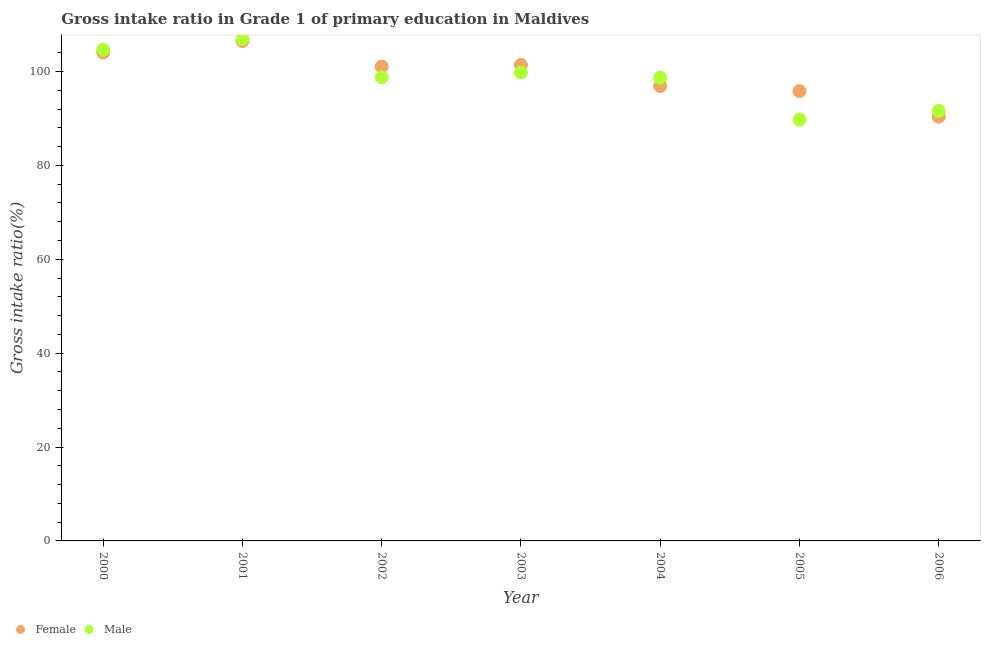How many different coloured dotlines are there?
Offer a very short reply. 2. What is the gross intake ratio(female) in 2002?
Keep it short and to the point. 101.03. Across all years, what is the maximum gross intake ratio(male)?
Provide a short and direct response. 106.93. Across all years, what is the minimum gross intake ratio(male)?
Offer a terse response. 89.74. In which year was the gross intake ratio(male) maximum?
Keep it short and to the point. 2001. What is the total gross intake ratio(female) in the graph?
Give a very brief answer. 695.97. What is the difference between the gross intake ratio(male) in 2001 and that in 2003?
Give a very brief answer. 7.13. What is the difference between the gross intake ratio(female) in 2002 and the gross intake ratio(male) in 2005?
Ensure brevity in your answer.  11.29. What is the average gross intake ratio(male) per year?
Provide a short and direct response. 98.59. In the year 2006, what is the difference between the gross intake ratio(female) and gross intake ratio(male)?
Make the answer very short. -1.24. In how many years, is the gross intake ratio(female) greater than 76 %?
Provide a short and direct response. 7. What is the ratio of the gross intake ratio(male) in 2005 to that in 2006?
Provide a succinct answer. 0.98. Is the difference between the gross intake ratio(female) in 2003 and 2004 greater than the difference between the gross intake ratio(male) in 2003 and 2004?
Your response must be concise. Yes. What is the difference between the highest and the second highest gross intake ratio(female)?
Your answer should be very brief. 2.44. What is the difference between the highest and the lowest gross intake ratio(female)?
Make the answer very short. 16.12. In how many years, is the gross intake ratio(female) greater than the average gross intake ratio(female) taken over all years?
Give a very brief answer. 4. Is the sum of the gross intake ratio(female) in 2002 and 2005 greater than the maximum gross intake ratio(male) across all years?
Offer a terse response. Yes. Is the gross intake ratio(female) strictly less than the gross intake ratio(male) over the years?
Ensure brevity in your answer.  No. How many years are there in the graph?
Your response must be concise. 7. How many legend labels are there?
Make the answer very short. 2. What is the title of the graph?
Give a very brief answer. Gross intake ratio in Grade 1 of primary education in Maldives. What is the label or title of the Y-axis?
Keep it short and to the point. Gross intake ratio(%). What is the Gross intake ratio(%) of Female in 2000?
Your answer should be very brief. 104.04. What is the Gross intake ratio(%) in Male in 2000?
Offer a terse response. 104.63. What is the Gross intake ratio(%) of Female in 2001?
Your answer should be compact. 106.48. What is the Gross intake ratio(%) of Male in 2001?
Offer a very short reply. 106.93. What is the Gross intake ratio(%) of Female in 2002?
Your response must be concise. 101.03. What is the Gross intake ratio(%) of Male in 2002?
Your response must be concise. 98.77. What is the Gross intake ratio(%) of Female in 2003?
Offer a very short reply. 101.36. What is the Gross intake ratio(%) in Male in 2003?
Provide a succinct answer. 99.81. What is the Gross intake ratio(%) in Female in 2004?
Offer a terse response. 96.88. What is the Gross intake ratio(%) of Male in 2004?
Ensure brevity in your answer.  98.67. What is the Gross intake ratio(%) of Female in 2005?
Your answer should be compact. 95.82. What is the Gross intake ratio(%) in Male in 2005?
Ensure brevity in your answer.  89.74. What is the Gross intake ratio(%) in Female in 2006?
Provide a succinct answer. 90.36. What is the Gross intake ratio(%) of Male in 2006?
Ensure brevity in your answer.  91.59. Across all years, what is the maximum Gross intake ratio(%) in Female?
Offer a terse response. 106.48. Across all years, what is the maximum Gross intake ratio(%) in Male?
Provide a succinct answer. 106.93. Across all years, what is the minimum Gross intake ratio(%) of Female?
Your answer should be very brief. 90.36. Across all years, what is the minimum Gross intake ratio(%) of Male?
Provide a short and direct response. 89.74. What is the total Gross intake ratio(%) in Female in the graph?
Give a very brief answer. 695.97. What is the total Gross intake ratio(%) of Male in the graph?
Your answer should be compact. 690.14. What is the difference between the Gross intake ratio(%) in Female in 2000 and that in 2001?
Keep it short and to the point. -2.44. What is the difference between the Gross intake ratio(%) in Male in 2000 and that in 2001?
Ensure brevity in your answer.  -2.3. What is the difference between the Gross intake ratio(%) in Female in 2000 and that in 2002?
Your answer should be very brief. 3.01. What is the difference between the Gross intake ratio(%) in Male in 2000 and that in 2002?
Offer a terse response. 5.86. What is the difference between the Gross intake ratio(%) in Female in 2000 and that in 2003?
Provide a short and direct response. 2.67. What is the difference between the Gross intake ratio(%) of Male in 2000 and that in 2003?
Your answer should be compact. 4.82. What is the difference between the Gross intake ratio(%) in Female in 2000 and that in 2004?
Your answer should be very brief. 7.16. What is the difference between the Gross intake ratio(%) of Male in 2000 and that in 2004?
Provide a short and direct response. 5.96. What is the difference between the Gross intake ratio(%) of Female in 2000 and that in 2005?
Provide a succinct answer. 8.22. What is the difference between the Gross intake ratio(%) in Male in 2000 and that in 2005?
Your answer should be very brief. 14.89. What is the difference between the Gross intake ratio(%) in Female in 2000 and that in 2006?
Provide a short and direct response. 13.68. What is the difference between the Gross intake ratio(%) of Male in 2000 and that in 2006?
Your answer should be very brief. 13.04. What is the difference between the Gross intake ratio(%) in Female in 2001 and that in 2002?
Offer a very short reply. 5.45. What is the difference between the Gross intake ratio(%) of Male in 2001 and that in 2002?
Keep it short and to the point. 8.16. What is the difference between the Gross intake ratio(%) of Female in 2001 and that in 2003?
Offer a very short reply. 5.12. What is the difference between the Gross intake ratio(%) in Male in 2001 and that in 2003?
Give a very brief answer. 7.13. What is the difference between the Gross intake ratio(%) of Female in 2001 and that in 2004?
Offer a very short reply. 9.6. What is the difference between the Gross intake ratio(%) of Male in 2001 and that in 2004?
Your answer should be compact. 8.27. What is the difference between the Gross intake ratio(%) of Female in 2001 and that in 2005?
Give a very brief answer. 10.67. What is the difference between the Gross intake ratio(%) of Male in 2001 and that in 2005?
Provide a succinct answer. 17.2. What is the difference between the Gross intake ratio(%) in Female in 2001 and that in 2006?
Your response must be concise. 16.12. What is the difference between the Gross intake ratio(%) in Male in 2001 and that in 2006?
Your response must be concise. 15.34. What is the difference between the Gross intake ratio(%) in Female in 2002 and that in 2003?
Ensure brevity in your answer.  -0.34. What is the difference between the Gross intake ratio(%) of Male in 2002 and that in 2003?
Offer a terse response. -1.03. What is the difference between the Gross intake ratio(%) of Female in 2002 and that in 2004?
Offer a terse response. 4.14. What is the difference between the Gross intake ratio(%) of Male in 2002 and that in 2004?
Make the answer very short. 0.1. What is the difference between the Gross intake ratio(%) in Female in 2002 and that in 2005?
Offer a terse response. 5.21. What is the difference between the Gross intake ratio(%) in Male in 2002 and that in 2005?
Give a very brief answer. 9.04. What is the difference between the Gross intake ratio(%) in Female in 2002 and that in 2006?
Your answer should be very brief. 10.67. What is the difference between the Gross intake ratio(%) of Male in 2002 and that in 2006?
Offer a terse response. 7.18. What is the difference between the Gross intake ratio(%) of Female in 2003 and that in 2004?
Ensure brevity in your answer.  4.48. What is the difference between the Gross intake ratio(%) in Male in 2003 and that in 2004?
Give a very brief answer. 1.14. What is the difference between the Gross intake ratio(%) of Female in 2003 and that in 2005?
Offer a terse response. 5.55. What is the difference between the Gross intake ratio(%) of Male in 2003 and that in 2005?
Your answer should be compact. 10.07. What is the difference between the Gross intake ratio(%) in Female in 2003 and that in 2006?
Make the answer very short. 11.01. What is the difference between the Gross intake ratio(%) in Male in 2003 and that in 2006?
Your answer should be very brief. 8.21. What is the difference between the Gross intake ratio(%) in Female in 2004 and that in 2005?
Your answer should be very brief. 1.07. What is the difference between the Gross intake ratio(%) of Male in 2004 and that in 2005?
Provide a succinct answer. 8.93. What is the difference between the Gross intake ratio(%) of Female in 2004 and that in 2006?
Provide a short and direct response. 6.53. What is the difference between the Gross intake ratio(%) in Male in 2004 and that in 2006?
Provide a short and direct response. 7.07. What is the difference between the Gross intake ratio(%) of Female in 2005 and that in 2006?
Make the answer very short. 5.46. What is the difference between the Gross intake ratio(%) of Male in 2005 and that in 2006?
Provide a short and direct response. -1.86. What is the difference between the Gross intake ratio(%) of Female in 2000 and the Gross intake ratio(%) of Male in 2001?
Ensure brevity in your answer.  -2.9. What is the difference between the Gross intake ratio(%) in Female in 2000 and the Gross intake ratio(%) in Male in 2002?
Your answer should be compact. 5.27. What is the difference between the Gross intake ratio(%) in Female in 2000 and the Gross intake ratio(%) in Male in 2003?
Your answer should be very brief. 4.23. What is the difference between the Gross intake ratio(%) in Female in 2000 and the Gross intake ratio(%) in Male in 2004?
Keep it short and to the point. 5.37. What is the difference between the Gross intake ratio(%) of Female in 2000 and the Gross intake ratio(%) of Male in 2005?
Give a very brief answer. 14.3. What is the difference between the Gross intake ratio(%) of Female in 2000 and the Gross intake ratio(%) of Male in 2006?
Your answer should be compact. 12.44. What is the difference between the Gross intake ratio(%) in Female in 2001 and the Gross intake ratio(%) in Male in 2002?
Give a very brief answer. 7.71. What is the difference between the Gross intake ratio(%) in Female in 2001 and the Gross intake ratio(%) in Male in 2003?
Offer a terse response. 6.68. What is the difference between the Gross intake ratio(%) of Female in 2001 and the Gross intake ratio(%) of Male in 2004?
Make the answer very short. 7.81. What is the difference between the Gross intake ratio(%) of Female in 2001 and the Gross intake ratio(%) of Male in 2005?
Your answer should be compact. 16.75. What is the difference between the Gross intake ratio(%) in Female in 2001 and the Gross intake ratio(%) in Male in 2006?
Offer a terse response. 14.89. What is the difference between the Gross intake ratio(%) in Female in 2002 and the Gross intake ratio(%) in Male in 2003?
Keep it short and to the point. 1.22. What is the difference between the Gross intake ratio(%) of Female in 2002 and the Gross intake ratio(%) of Male in 2004?
Keep it short and to the point. 2.36. What is the difference between the Gross intake ratio(%) of Female in 2002 and the Gross intake ratio(%) of Male in 2005?
Give a very brief answer. 11.29. What is the difference between the Gross intake ratio(%) in Female in 2002 and the Gross intake ratio(%) in Male in 2006?
Make the answer very short. 9.43. What is the difference between the Gross intake ratio(%) of Female in 2003 and the Gross intake ratio(%) of Male in 2004?
Make the answer very short. 2.7. What is the difference between the Gross intake ratio(%) in Female in 2003 and the Gross intake ratio(%) in Male in 2005?
Make the answer very short. 11.63. What is the difference between the Gross intake ratio(%) of Female in 2003 and the Gross intake ratio(%) of Male in 2006?
Provide a succinct answer. 9.77. What is the difference between the Gross intake ratio(%) of Female in 2004 and the Gross intake ratio(%) of Male in 2005?
Provide a succinct answer. 7.15. What is the difference between the Gross intake ratio(%) of Female in 2004 and the Gross intake ratio(%) of Male in 2006?
Offer a very short reply. 5.29. What is the difference between the Gross intake ratio(%) in Female in 2005 and the Gross intake ratio(%) in Male in 2006?
Offer a very short reply. 4.22. What is the average Gross intake ratio(%) in Female per year?
Make the answer very short. 99.42. What is the average Gross intake ratio(%) in Male per year?
Give a very brief answer. 98.59. In the year 2000, what is the difference between the Gross intake ratio(%) in Female and Gross intake ratio(%) in Male?
Your answer should be very brief. -0.59. In the year 2001, what is the difference between the Gross intake ratio(%) of Female and Gross intake ratio(%) of Male?
Make the answer very short. -0.45. In the year 2002, what is the difference between the Gross intake ratio(%) in Female and Gross intake ratio(%) in Male?
Ensure brevity in your answer.  2.26. In the year 2003, what is the difference between the Gross intake ratio(%) of Female and Gross intake ratio(%) of Male?
Ensure brevity in your answer.  1.56. In the year 2004, what is the difference between the Gross intake ratio(%) of Female and Gross intake ratio(%) of Male?
Offer a terse response. -1.78. In the year 2005, what is the difference between the Gross intake ratio(%) of Female and Gross intake ratio(%) of Male?
Give a very brief answer. 6.08. In the year 2006, what is the difference between the Gross intake ratio(%) in Female and Gross intake ratio(%) in Male?
Offer a very short reply. -1.24. What is the ratio of the Gross intake ratio(%) of Female in 2000 to that in 2001?
Keep it short and to the point. 0.98. What is the ratio of the Gross intake ratio(%) in Male in 2000 to that in 2001?
Your response must be concise. 0.98. What is the ratio of the Gross intake ratio(%) in Female in 2000 to that in 2002?
Your answer should be very brief. 1.03. What is the ratio of the Gross intake ratio(%) in Male in 2000 to that in 2002?
Offer a very short reply. 1.06. What is the ratio of the Gross intake ratio(%) in Female in 2000 to that in 2003?
Your response must be concise. 1.03. What is the ratio of the Gross intake ratio(%) of Male in 2000 to that in 2003?
Make the answer very short. 1.05. What is the ratio of the Gross intake ratio(%) of Female in 2000 to that in 2004?
Give a very brief answer. 1.07. What is the ratio of the Gross intake ratio(%) in Male in 2000 to that in 2004?
Make the answer very short. 1.06. What is the ratio of the Gross intake ratio(%) in Female in 2000 to that in 2005?
Offer a terse response. 1.09. What is the ratio of the Gross intake ratio(%) of Male in 2000 to that in 2005?
Give a very brief answer. 1.17. What is the ratio of the Gross intake ratio(%) in Female in 2000 to that in 2006?
Your answer should be very brief. 1.15. What is the ratio of the Gross intake ratio(%) in Male in 2000 to that in 2006?
Provide a short and direct response. 1.14. What is the ratio of the Gross intake ratio(%) of Female in 2001 to that in 2002?
Offer a terse response. 1.05. What is the ratio of the Gross intake ratio(%) of Male in 2001 to that in 2002?
Provide a short and direct response. 1.08. What is the ratio of the Gross intake ratio(%) of Female in 2001 to that in 2003?
Offer a terse response. 1.05. What is the ratio of the Gross intake ratio(%) in Male in 2001 to that in 2003?
Keep it short and to the point. 1.07. What is the ratio of the Gross intake ratio(%) in Female in 2001 to that in 2004?
Make the answer very short. 1.1. What is the ratio of the Gross intake ratio(%) of Male in 2001 to that in 2004?
Your response must be concise. 1.08. What is the ratio of the Gross intake ratio(%) of Female in 2001 to that in 2005?
Keep it short and to the point. 1.11. What is the ratio of the Gross intake ratio(%) of Male in 2001 to that in 2005?
Ensure brevity in your answer.  1.19. What is the ratio of the Gross intake ratio(%) in Female in 2001 to that in 2006?
Your response must be concise. 1.18. What is the ratio of the Gross intake ratio(%) of Male in 2001 to that in 2006?
Your answer should be compact. 1.17. What is the ratio of the Gross intake ratio(%) in Female in 2002 to that in 2004?
Your response must be concise. 1.04. What is the ratio of the Gross intake ratio(%) in Female in 2002 to that in 2005?
Provide a short and direct response. 1.05. What is the ratio of the Gross intake ratio(%) of Male in 2002 to that in 2005?
Give a very brief answer. 1.1. What is the ratio of the Gross intake ratio(%) of Female in 2002 to that in 2006?
Offer a terse response. 1.12. What is the ratio of the Gross intake ratio(%) of Male in 2002 to that in 2006?
Your answer should be very brief. 1.08. What is the ratio of the Gross intake ratio(%) in Female in 2003 to that in 2004?
Offer a very short reply. 1.05. What is the ratio of the Gross intake ratio(%) in Male in 2003 to that in 2004?
Your answer should be very brief. 1.01. What is the ratio of the Gross intake ratio(%) in Female in 2003 to that in 2005?
Your answer should be compact. 1.06. What is the ratio of the Gross intake ratio(%) of Male in 2003 to that in 2005?
Your answer should be very brief. 1.11. What is the ratio of the Gross intake ratio(%) in Female in 2003 to that in 2006?
Offer a terse response. 1.12. What is the ratio of the Gross intake ratio(%) of Male in 2003 to that in 2006?
Ensure brevity in your answer.  1.09. What is the ratio of the Gross intake ratio(%) of Female in 2004 to that in 2005?
Ensure brevity in your answer.  1.01. What is the ratio of the Gross intake ratio(%) of Male in 2004 to that in 2005?
Your answer should be compact. 1.1. What is the ratio of the Gross intake ratio(%) in Female in 2004 to that in 2006?
Your response must be concise. 1.07. What is the ratio of the Gross intake ratio(%) of Male in 2004 to that in 2006?
Your response must be concise. 1.08. What is the ratio of the Gross intake ratio(%) of Female in 2005 to that in 2006?
Provide a short and direct response. 1.06. What is the ratio of the Gross intake ratio(%) in Male in 2005 to that in 2006?
Give a very brief answer. 0.98. What is the difference between the highest and the second highest Gross intake ratio(%) of Female?
Keep it short and to the point. 2.44. What is the difference between the highest and the second highest Gross intake ratio(%) of Male?
Offer a very short reply. 2.3. What is the difference between the highest and the lowest Gross intake ratio(%) in Female?
Your response must be concise. 16.12. What is the difference between the highest and the lowest Gross intake ratio(%) in Male?
Your answer should be very brief. 17.2. 